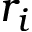Convert formula to latex. <formula><loc_0><loc_0><loc_500><loc_500>r _ { i }</formula> 